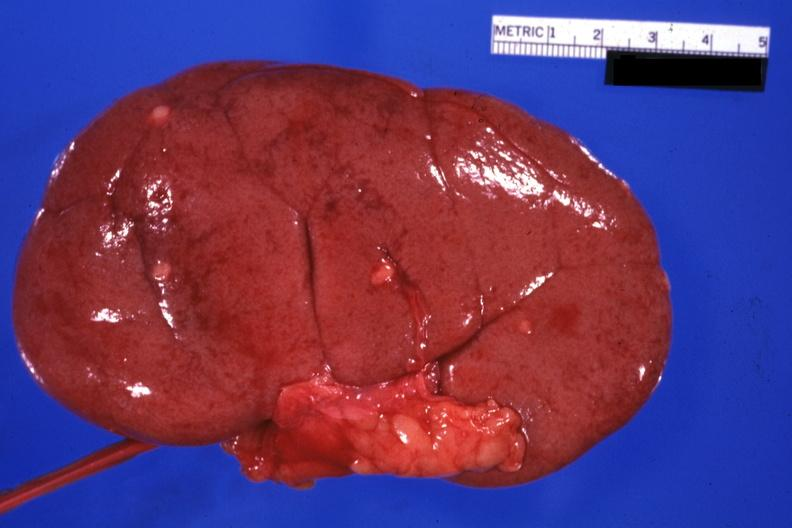s side present?
Answer the question using a single word or phrase. No 